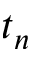Convert formula to latex. <formula><loc_0><loc_0><loc_500><loc_500>t _ { n }</formula> 